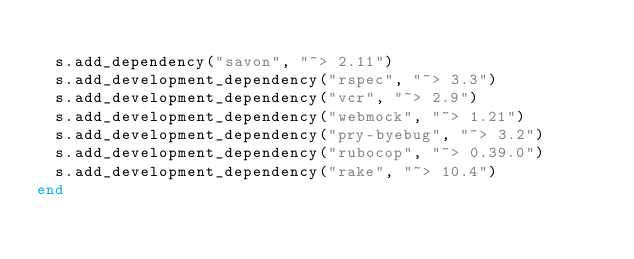<code> <loc_0><loc_0><loc_500><loc_500><_Ruby_>
  s.add_dependency("savon", "~> 2.11")
  s.add_development_dependency("rspec", "~> 3.3")
  s.add_development_dependency("vcr", "~> 2.9")
  s.add_development_dependency("webmock", "~> 1.21")
  s.add_development_dependency("pry-byebug", "~> 3.2")
  s.add_development_dependency("rubocop", "~> 0.39.0")
  s.add_development_dependency("rake", "~> 10.4")
end
</code> 